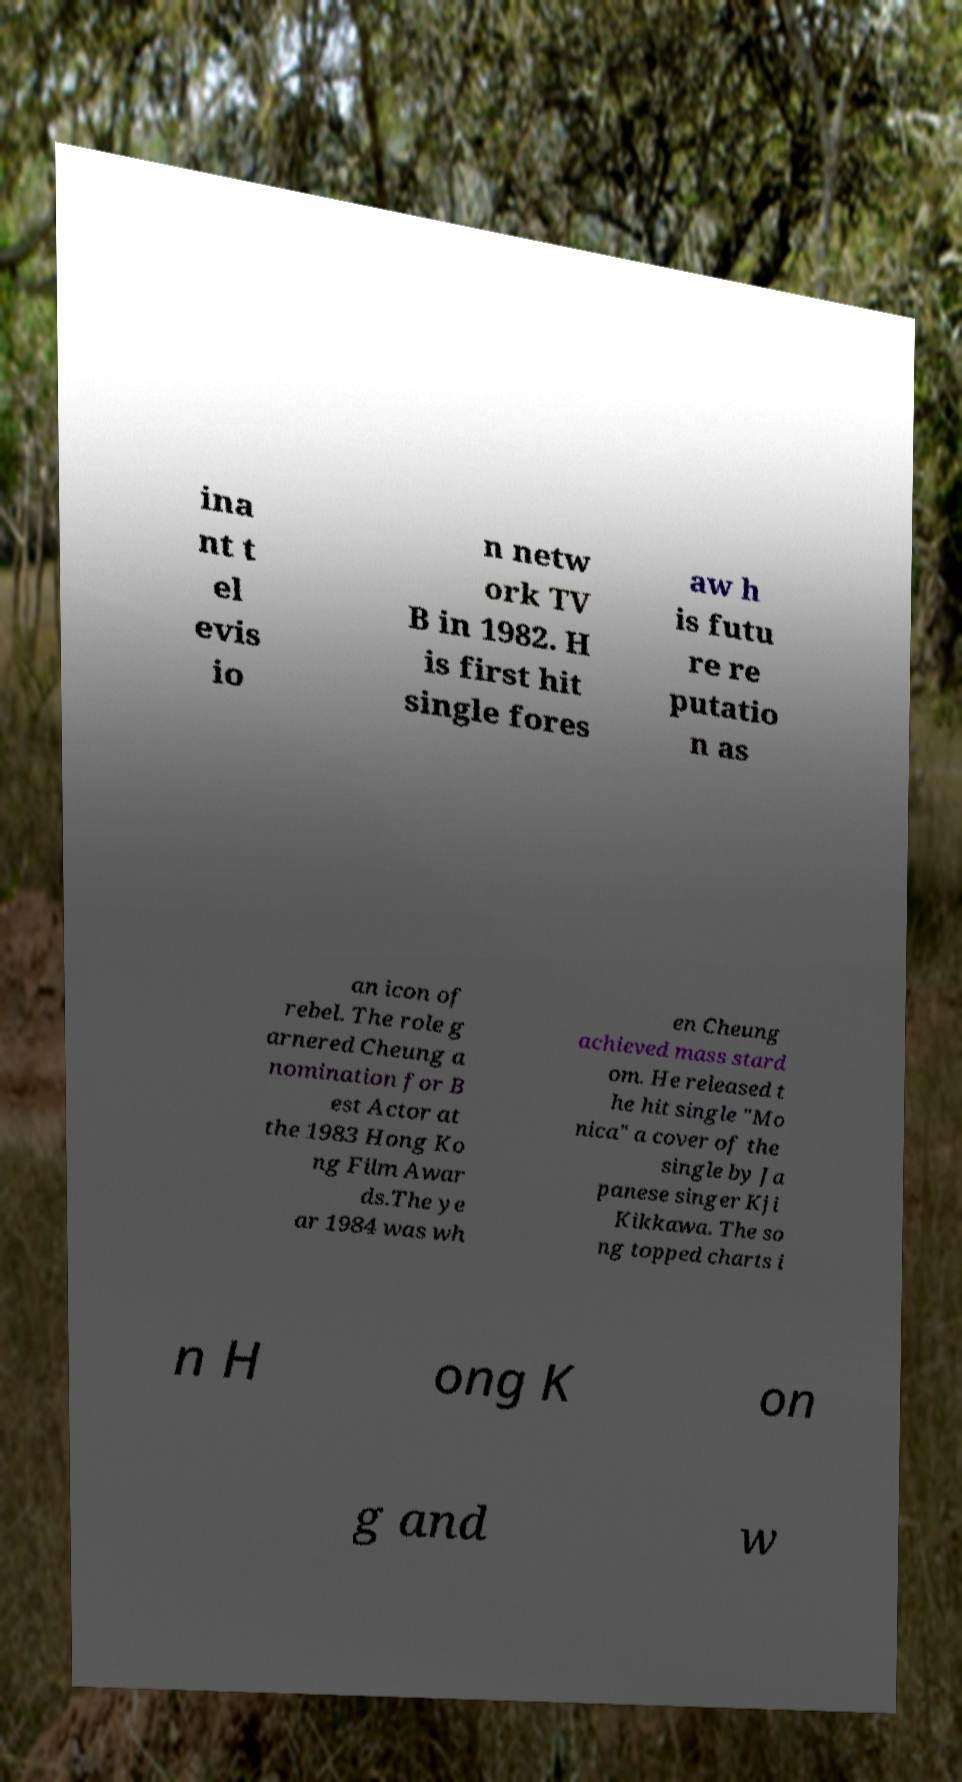What messages or text are displayed in this image? I need them in a readable, typed format. ina nt t el evis io n netw ork TV B in 1982. H is first hit single fores aw h is futu re re putatio n as an icon of rebel. The role g arnered Cheung a nomination for B est Actor at the 1983 Hong Ko ng Film Awar ds.The ye ar 1984 was wh en Cheung achieved mass stard om. He released t he hit single "Mo nica" a cover of the single by Ja panese singer Kji Kikkawa. The so ng topped charts i n H ong K on g and w 